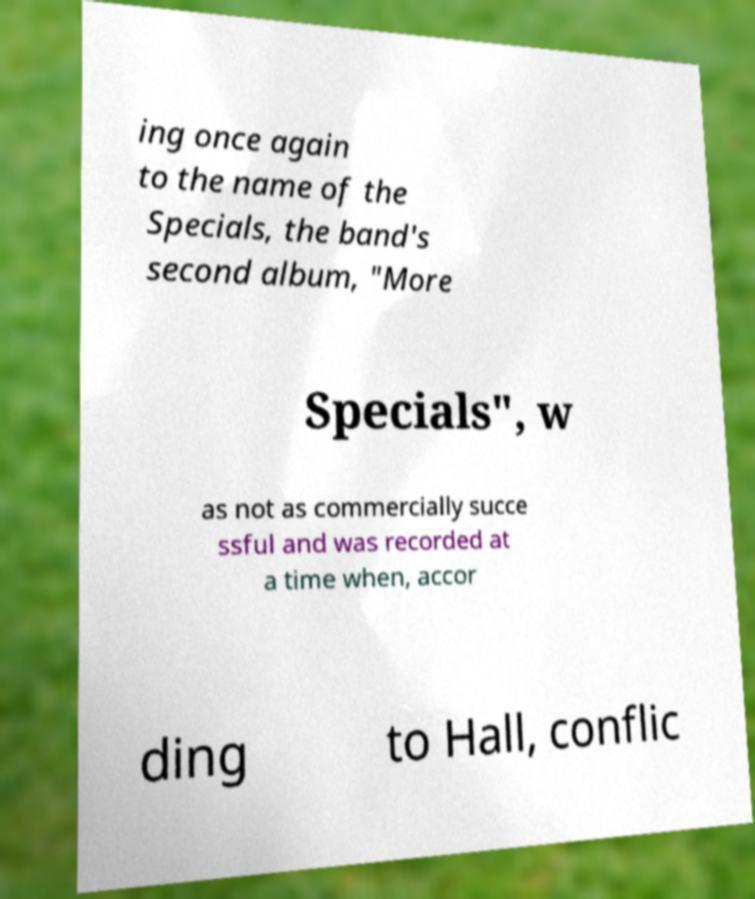Please identify and transcribe the text found in this image. ing once again to the name of the Specials, the band's second album, "More Specials", w as not as commercially succe ssful and was recorded at a time when, accor ding to Hall, conflic 